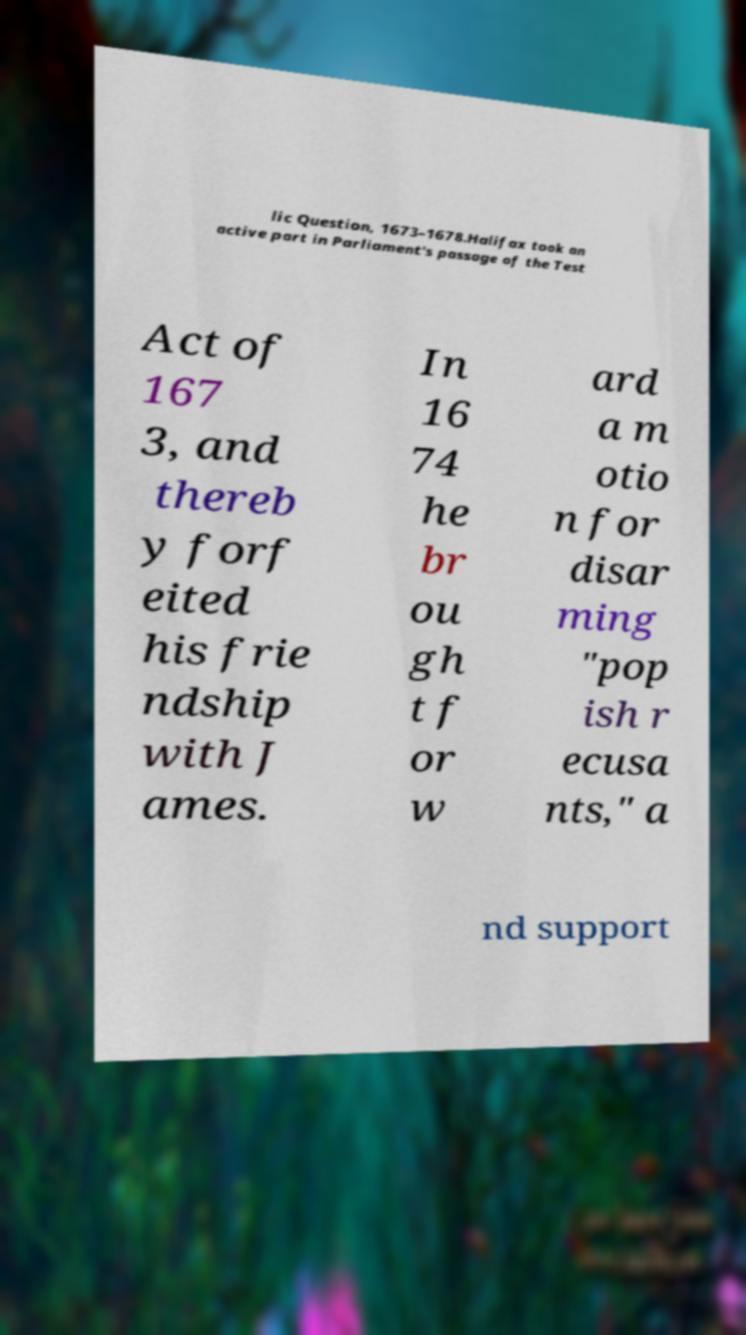Please read and relay the text visible in this image. What does it say? lic Question, 1673–1678.Halifax took an active part in Parliament's passage of the Test Act of 167 3, and thereb y forf eited his frie ndship with J ames. In 16 74 he br ou gh t f or w ard a m otio n for disar ming "pop ish r ecusa nts," a nd support 